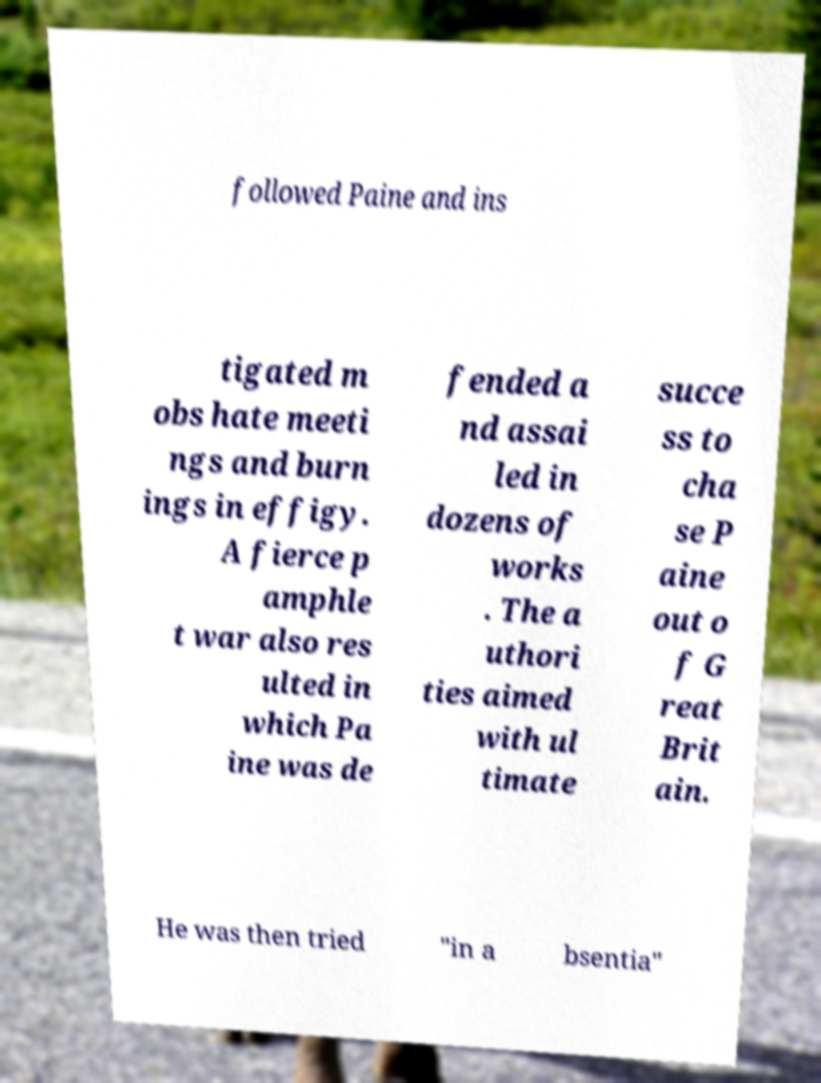I need the written content from this picture converted into text. Can you do that? followed Paine and ins tigated m obs hate meeti ngs and burn ings in effigy. A fierce p amphle t war also res ulted in which Pa ine was de fended a nd assai led in dozens of works . The a uthori ties aimed with ul timate succe ss to cha se P aine out o f G reat Brit ain. He was then tried "in a bsentia" 